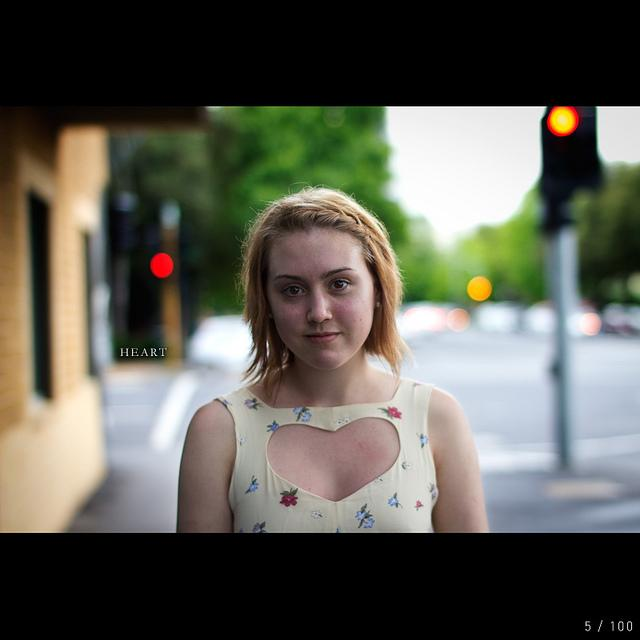What age group is this person in? Please explain your reasoning. 18-30. The person is a young adult. 